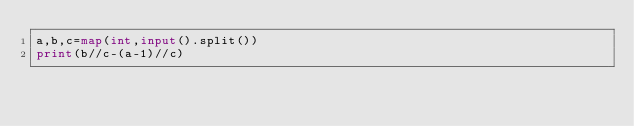<code> <loc_0><loc_0><loc_500><loc_500><_Python_>a,b,c=map(int,input().split())
print(b//c-(a-1)//c)</code> 